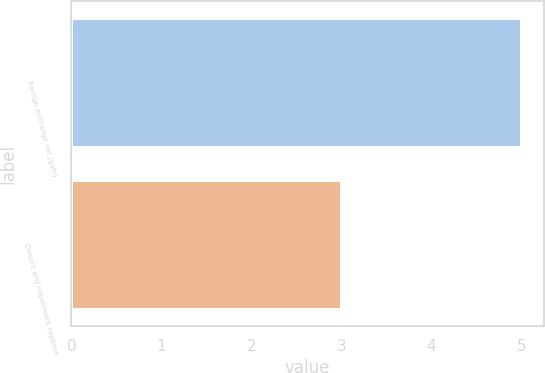<chart> <loc_0><loc_0><loc_500><loc_500><bar_chart><fcel>Foreign exchange net (gain)<fcel>Closure and impairment expense<nl><fcel>5<fcel>3<nl></chart> 